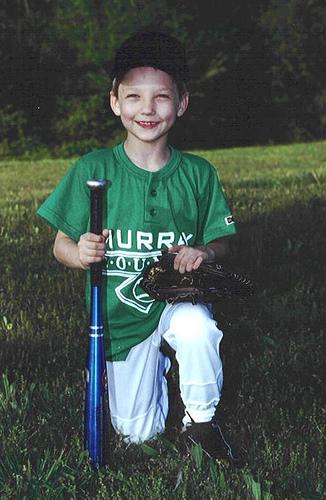What is the boy holding?
Concise answer only. Baseball bat and glove. What color is the bat?
Be succinct. Blue. What color is the uniform?
Concise answer only. Green and white. 